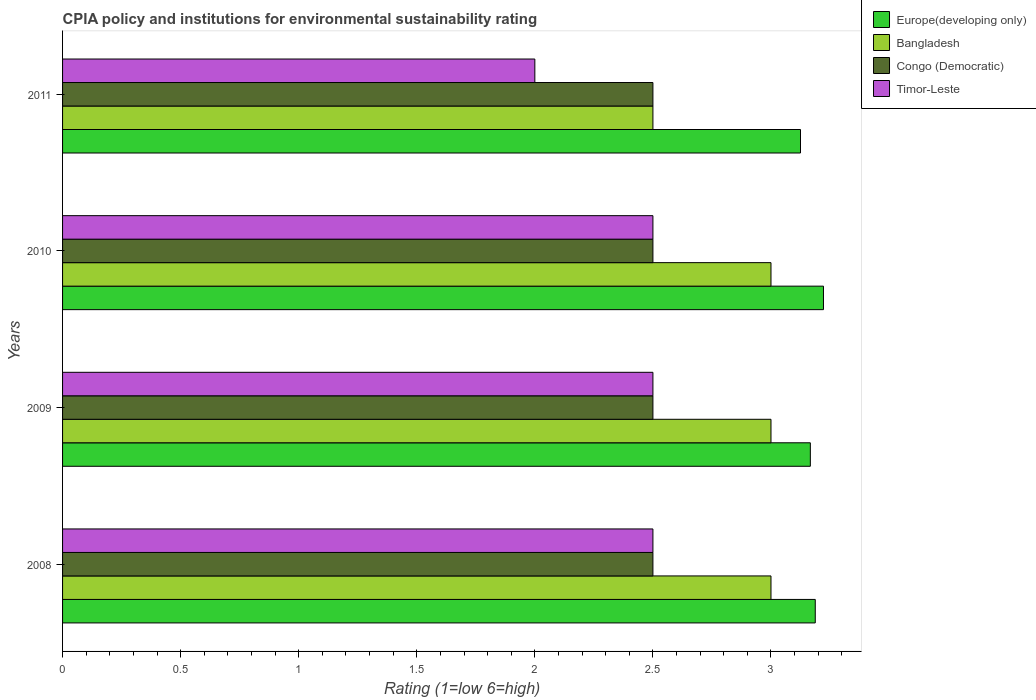How many different coloured bars are there?
Ensure brevity in your answer.  4. How many groups of bars are there?
Provide a succinct answer. 4. Are the number of bars per tick equal to the number of legend labels?
Your answer should be compact. Yes. Are the number of bars on each tick of the Y-axis equal?
Your response must be concise. Yes. How many bars are there on the 2nd tick from the bottom?
Provide a short and direct response. 4. What is the label of the 4th group of bars from the top?
Keep it short and to the point. 2008. In how many cases, is the number of bars for a given year not equal to the number of legend labels?
Provide a short and direct response. 0. What is the CPIA rating in Congo (Democratic) in 2010?
Ensure brevity in your answer.  2.5. Across all years, what is the maximum CPIA rating in Timor-Leste?
Your answer should be compact. 2.5. What is the total CPIA rating in Europe(developing only) in the graph?
Ensure brevity in your answer.  12.7. What is the difference between the CPIA rating in Congo (Democratic) in 2008 and that in 2011?
Give a very brief answer. 0. What is the difference between the CPIA rating in Congo (Democratic) in 2010 and the CPIA rating in Europe(developing only) in 2009?
Your response must be concise. -0.67. What is the average CPIA rating in Bangladesh per year?
Offer a terse response. 2.88. In the year 2011, what is the difference between the CPIA rating in Bangladesh and CPIA rating in Europe(developing only)?
Give a very brief answer. -0.62. In how many years, is the CPIA rating in Congo (Democratic) greater than 0.9 ?
Provide a short and direct response. 4. What is the ratio of the CPIA rating in Timor-Leste in 2009 to that in 2011?
Give a very brief answer. 1.25. Is the CPIA rating in Timor-Leste in 2008 less than that in 2010?
Your answer should be very brief. No. In how many years, is the CPIA rating in Europe(developing only) greater than the average CPIA rating in Europe(developing only) taken over all years?
Offer a very short reply. 2. Is the sum of the CPIA rating in Europe(developing only) in 2008 and 2009 greater than the maximum CPIA rating in Congo (Democratic) across all years?
Provide a short and direct response. Yes. Is it the case that in every year, the sum of the CPIA rating in Congo (Democratic) and CPIA rating in Timor-Leste is greater than the sum of CPIA rating in Europe(developing only) and CPIA rating in Bangladesh?
Your response must be concise. No. What does the 2nd bar from the top in 2008 represents?
Make the answer very short. Congo (Democratic). What does the 2nd bar from the bottom in 2011 represents?
Provide a succinct answer. Bangladesh. Is it the case that in every year, the sum of the CPIA rating in Bangladesh and CPIA rating in Europe(developing only) is greater than the CPIA rating in Timor-Leste?
Ensure brevity in your answer.  Yes. How many bars are there?
Give a very brief answer. 16. How many years are there in the graph?
Make the answer very short. 4. Does the graph contain any zero values?
Your answer should be very brief. No. Does the graph contain grids?
Provide a short and direct response. No. Where does the legend appear in the graph?
Give a very brief answer. Top right. How are the legend labels stacked?
Your answer should be compact. Vertical. What is the title of the graph?
Make the answer very short. CPIA policy and institutions for environmental sustainability rating. What is the Rating (1=low 6=high) in Europe(developing only) in 2008?
Your answer should be very brief. 3.19. What is the Rating (1=low 6=high) in Congo (Democratic) in 2008?
Provide a short and direct response. 2.5. What is the Rating (1=low 6=high) in Timor-Leste in 2008?
Provide a short and direct response. 2.5. What is the Rating (1=low 6=high) in Europe(developing only) in 2009?
Offer a very short reply. 3.17. What is the Rating (1=low 6=high) in Congo (Democratic) in 2009?
Keep it short and to the point. 2.5. What is the Rating (1=low 6=high) of Timor-Leste in 2009?
Your answer should be very brief. 2.5. What is the Rating (1=low 6=high) of Europe(developing only) in 2010?
Ensure brevity in your answer.  3.22. What is the Rating (1=low 6=high) in Bangladesh in 2010?
Provide a succinct answer. 3. What is the Rating (1=low 6=high) in Timor-Leste in 2010?
Your answer should be compact. 2.5. What is the Rating (1=low 6=high) in Europe(developing only) in 2011?
Your answer should be very brief. 3.12. Across all years, what is the maximum Rating (1=low 6=high) of Europe(developing only)?
Provide a short and direct response. 3.22. Across all years, what is the maximum Rating (1=low 6=high) in Bangladesh?
Your response must be concise. 3. Across all years, what is the maximum Rating (1=low 6=high) in Congo (Democratic)?
Offer a very short reply. 2.5. Across all years, what is the maximum Rating (1=low 6=high) of Timor-Leste?
Ensure brevity in your answer.  2.5. Across all years, what is the minimum Rating (1=low 6=high) of Europe(developing only)?
Provide a short and direct response. 3.12. Across all years, what is the minimum Rating (1=low 6=high) in Bangladesh?
Offer a very short reply. 2.5. What is the total Rating (1=low 6=high) of Europe(developing only) in the graph?
Provide a short and direct response. 12.7. What is the total Rating (1=low 6=high) of Bangladesh in the graph?
Your response must be concise. 11.5. What is the total Rating (1=low 6=high) of Congo (Democratic) in the graph?
Offer a terse response. 10. What is the total Rating (1=low 6=high) in Timor-Leste in the graph?
Ensure brevity in your answer.  9.5. What is the difference between the Rating (1=low 6=high) of Europe(developing only) in 2008 and that in 2009?
Offer a terse response. 0.02. What is the difference between the Rating (1=low 6=high) of Bangladesh in 2008 and that in 2009?
Provide a short and direct response. 0. What is the difference between the Rating (1=low 6=high) in Europe(developing only) in 2008 and that in 2010?
Your answer should be very brief. -0.03. What is the difference between the Rating (1=low 6=high) in Bangladesh in 2008 and that in 2010?
Your answer should be very brief. 0. What is the difference between the Rating (1=low 6=high) of Congo (Democratic) in 2008 and that in 2010?
Your answer should be compact. 0. What is the difference between the Rating (1=low 6=high) of Europe(developing only) in 2008 and that in 2011?
Make the answer very short. 0.06. What is the difference between the Rating (1=low 6=high) of Bangladesh in 2008 and that in 2011?
Your answer should be very brief. 0.5. What is the difference between the Rating (1=low 6=high) of Europe(developing only) in 2009 and that in 2010?
Make the answer very short. -0.06. What is the difference between the Rating (1=low 6=high) in Bangladesh in 2009 and that in 2010?
Your response must be concise. 0. What is the difference between the Rating (1=low 6=high) in Congo (Democratic) in 2009 and that in 2010?
Give a very brief answer. 0. What is the difference between the Rating (1=low 6=high) of Timor-Leste in 2009 and that in 2010?
Make the answer very short. 0. What is the difference between the Rating (1=low 6=high) in Europe(developing only) in 2009 and that in 2011?
Keep it short and to the point. 0.04. What is the difference between the Rating (1=low 6=high) of Bangladesh in 2009 and that in 2011?
Keep it short and to the point. 0.5. What is the difference between the Rating (1=low 6=high) in Europe(developing only) in 2010 and that in 2011?
Your answer should be very brief. 0.1. What is the difference between the Rating (1=low 6=high) of Congo (Democratic) in 2010 and that in 2011?
Give a very brief answer. 0. What is the difference between the Rating (1=low 6=high) of Europe(developing only) in 2008 and the Rating (1=low 6=high) of Bangladesh in 2009?
Provide a succinct answer. 0.19. What is the difference between the Rating (1=low 6=high) of Europe(developing only) in 2008 and the Rating (1=low 6=high) of Congo (Democratic) in 2009?
Your response must be concise. 0.69. What is the difference between the Rating (1=low 6=high) of Europe(developing only) in 2008 and the Rating (1=low 6=high) of Timor-Leste in 2009?
Your answer should be compact. 0.69. What is the difference between the Rating (1=low 6=high) of Europe(developing only) in 2008 and the Rating (1=low 6=high) of Bangladesh in 2010?
Give a very brief answer. 0.19. What is the difference between the Rating (1=low 6=high) of Europe(developing only) in 2008 and the Rating (1=low 6=high) of Congo (Democratic) in 2010?
Keep it short and to the point. 0.69. What is the difference between the Rating (1=low 6=high) in Europe(developing only) in 2008 and the Rating (1=low 6=high) in Timor-Leste in 2010?
Offer a terse response. 0.69. What is the difference between the Rating (1=low 6=high) in Bangladesh in 2008 and the Rating (1=low 6=high) in Congo (Democratic) in 2010?
Offer a terse response. 0.5. What is the difference between the Rating (1=low 6=high) in Europe(developing only) in 2008 and the Rating (1=low 6=high) in Bangladesh in 2011?
Provide a short and direct response. 0.69. What is the difference between the Rating (1=low 6=high) of Europe(developing only) in 2008 and the Rating (1=low 6=high) of Congo (Democratic) in 2011?
Ensure brevity in your answer.  0.69. What is the difference between the Rating (1=low 6=high) in Europe(developing only) in 2008 and the Rating (1=low 6=high) in Timor-Leste in 2011?
Give a very brief answer. 1.19. What is the difference between the Rating (1=low 6=high) of Bangladesh in 2008 and the Rating (1=low 6=high) of Congo (Democratic) in 2011?
Offer a very short reply. 0.5. What is the difference between the Rating (1=low 6=high) of Bangladesh in 2008 and the Rating (1=low 6=high) of Timor-Leste in 2011?
Keep it short and to the point. 1. What is the difference between the Rating (1=low 6=high) in Congo (Democratic) in 2008 and the Rating (1=low 6=high) in Timor-Leste in 2011?
Provide a short and direct response. 0.5. What is the difference between the Rating (1=low 6=high) of Europe(developing only) in 2009 and the Rating (1=low 6=high) of Bangladesh in 2010?
Keep it short and to the point. 0.17. What is the difference between the Rating (1=low 6=high) in Europe(developing only) in 2009 and the Rating (1=low 6=high) in Timor-Leste in 2010?
Give a very brief answer. 0.67. What is the difference between the Rating (1=low 6=high) in Bangladesh in 2009 and the Rating (1=low 6=high) in Congo (Democratic) in 2010?
Your answer should be very brief. 0.5. What is the difference between the Rating (1=low 6=high) in Bangladesh in 2009 and the Rating (1=low 6=high) in Timor-Leste in 2010?
Keep it short and to the point. 0.5. What is the difference between the Rating (1=low 6=high) of Congo (Democratic) in 2009 and the Rating (1=low 6=high) of Timor-Leste in 2010?
Your answer should be very brief. 0. What is the difference between the Rating (1=low 6=high) of Europe(developing only) in 2009 and the Rating (1=low 6=high) of Timor-Leste in 2011?
Make the answer very short. 1.17. What is the difference between the Rating (1=low 6=high) of Congo (Democratic) in 2009 and the Rating (1=low 6=high) of Timor-Leste in 2011?
Ensure brevity in your answer.  0.5. What is the difference between the Rating (1=low 6=high) of Europe(developing only) in 2010 and the Rating (1=low 6=high) of Bangladesh in 2011?
Your answer should be compact. 0.72. What is the difference between the Rating (1=low 6=high) in Europe(developing only) in 2010 and the Rating (1=low 6=high) in Congo (Democratic) in 2011?
Ensure brevity in your answer.  0.72. What is the difference between the Rating (1=low 6=high) of Europe(developing only) in 2010 and the Rating (1=low 6=high) of Timor-Leste in 2011?
Your answer should be compact. 1.22. What is the difference between the Rating (1=low 6=high) in Bangladesh in 2010 and the Rating (1=low 6=high) in Congo (Democratic) in 2011?
Keep it short and to the point. 0.5. What is the difference between the Rating (1=low 6=high) in Bangladesh in 2010 and the Rating (1=low 6=high) in Timor-Leste in 2011?
Ensure brevity in your answer.  1. What is the average Rating (1=low 6=high) in Europe(developing only) per year?
Provide a succinct answer. 3.18. What is the average Rating (1=low 6=high) of Bangladesh per year?
Keep it short and to the point. 2.88. What is the average Rating (1=low 6=high) in Congo (Democratic) per year?
Offer a very short reply. 2.5. What is the average Rating (1=low 6=high) of Timor-Leste per year?
Offer a terse response. 2.38. In the year 2008, what is the difference between the Rating (1=low 6=high) of Europe(developing only) and Rating (1=low 6=high) of Bangladesh?
Provide a short and direct response. 0.19. In the year 2008, what is the difference between the Rating (1=low 6=high) of Europe(developing only) and Rating (1=low 6=high) of Congo (Democratic)?
Keep it short and to the point. 0.69. In the year 2008, what is the difference between the Rating (1=low 6=high) of Europe(developing only) and Rating (1=low 6=high) of Timor-Leste?
Your response must be concise. 0.69. In the year 2008, what is the difference between the Rating (1=low 6=high) in Bangladesh and Rating (1=low 6=high) in Congo (Democratic)?
Provide a short and direct response. 0.5. In the year 2008, what is the difference between the Rating (1=low 6=high) in Bangladesh and Rating (1=low 6=high) in Timor-Leste?
Ensure brevity in your answer.  0.5. In the year 2008, what is the difference between the Rating (1=low 6=high) of Congo (Democratic) and Rating (1=low 6=high) of Timor-Leste?
Your response must be concise. 0. In the year 2009, what is the difference between the Rating (1=low 6=high) of Europe(developing only) and Rating (1=low 6=high) of Bangladesh?
Your answer should be compact. 0.17. In the year 2009, what is the difference between the Rating (1=low 6=high) in Congo (Democratic) and Rating (1=low 6=high) in Timor-Leste?
Keep it short and to the point. 0. In the year 2010, what is the difference between the Rating (1=low 6=high) in Europe(developing only) and Rating (1=low 6=high) in Bangladesh?
Your answer should be very brief. 0.22. In the year 2010, what is the difference between the Rating (1=low 6=high) of Europe(developing only) and Rating (1=low 6=high) of Congo (Democratic)?
Keep it short and to the point. 0.72. In the year 2010, what is the difference between the Rating (1=low 6=high) of Europe(developing only) and Rating (1=low 6=high) of Timor-Leste?
Offer a very short reply. 0.72. In the year 2010, what is the difference between the Rating (1=low 6=high) of Bangladesh and Rating (1=low 6=high) of Timor-Leste?
Provide a short and direct response. 0.5. In the year 2010, what is the difference between the Rating (1=low 6=high) in Congo (Democratic) and Rating (1=low 6=high) in Timor-Leste?
Your answer should be very brief. 0. In the year 2011, what is the difference between the Rating (1=low 6=high) in Europe(developing only) and Rating (1=low 6=high) in Bangladesh?
Provide a short and direct response. 0.62. In the year 2011, what is the difference between the Rating (1=low 6=high) in Bangladesh and Rating (1=low 6=high) in Congo (Democratic)?
Make the answer very short. 0. What is the ratio of the Rating (1=low 6=high) in Europe(developing only) in 2008 to that in 2009?
Provide a succinct answer. 1.01. What is the ratio of the Rating (1=low 6=high) in Bangladesh in 2008 to that in 2009?
Offer a very short reply. 1. What is the ratio of the Rating (1=low 6=high) of Congo (Democratic) in 2008 to that in 2009?
Keep it short and to the point. 1. What is the ratio of the Rating (1=low 6=high) of Timor-Leste in 2008 to that in 2009?
Keep it short and to the point. 1. What is the ratio of the Rating (1=low 6=high) of Europe(developing only) in 2008 to that in 2010?
Your response must be concise. 0.99. What is the ratio of the Rating (1=low 6=high) of Bangladesh in 2008 to that in 2010?
Ensure brevity in your answer.  1. What is the ratio of the Rating (1=low 6=high) in Bangladesh in 2008 to that in 2011?
Ensure brevity in your answer.  1.2. What is the ratio of the Rating (1=low 6=high) in Congo (Democratic) in 2008 to that in 2011?
Your answer should be very brief. 1. What is the ratio of the Rating (1=low 6=high) of Europe(developing only) in 2009 to that in 2010?
Offer a terse response. 0.98. What is the ratio of the Rating (1=low 6=high) of Bangladesh in 2009 to that in 2010?
Provide a succinct answer. 1. What is the ratio of the Rating (1=low 6=high) in Timor-Leste in 2009 to that in 2010?
Make the answer very short. 1. What is the ratio of the Rating (1=low 6=high) in Europe(developing only) in 2009 to that in 2011?
Make the answer very short. 1.01. What is the ratio of the Rating (1=low 6=high) of Bangladesh in 2009 to that in 2011?
Provide a succinct answer. 1.2. What is the ratio of the Rating (1=low 6=high) of Congo (Democratic) in 2009 to that in 2011?
Offer a very short reply. 1. What is the ratio of the Rating (1=low 6=high) in Timor-Leste in 2009 to that in 2011?
Keep it short and to the point. 1.25. What is the ratio of the Rating (1=low 6=high) in Europe(developing only) in 2010 to that in 2011?
Offer a terse response. 1.03. What is the ratio of the Rating (1=low 6=high) of Bangladesh in 2010 to that in 2011?
Give a very brief answer. 1.2. What is the ratio of the Rating (1=low 6=high) of Timor-Leste in 2010 to that in 2011?
Offer a very short reply. 1.25. What is the difference between the highest and the second highest Rating (1=low 6=high) in Europe(developing only)?
Your response must be concise. 0.03. What is the difference between the highest and the second highest Rating (1=low 6=high) in Bangladesh?
Your answer should be compact. 0. What is the difference between the highest and the second highest Rating (1=low 6=high) in Timor-Leste?
Make the answer very short. 0. What is the difference between the highest and the lowest Rating (1=low 6=high) in Europe(developing only)?
Offer a terse response. 0.1. What is the difference between the highest and the lowest Rating (1=low 6=high) in Bangladesh?
Give a very brief answer. 0.5. What is the difference between the highest and the lowest Rating (1=low 6=high) of Congo (Democratic)?
Provide a succinct answer. 0. What is the difference between the highest and the lowest Rating (1=low 6=high) in Timor-Leste?
Keep it short and to the point. 0.5. 